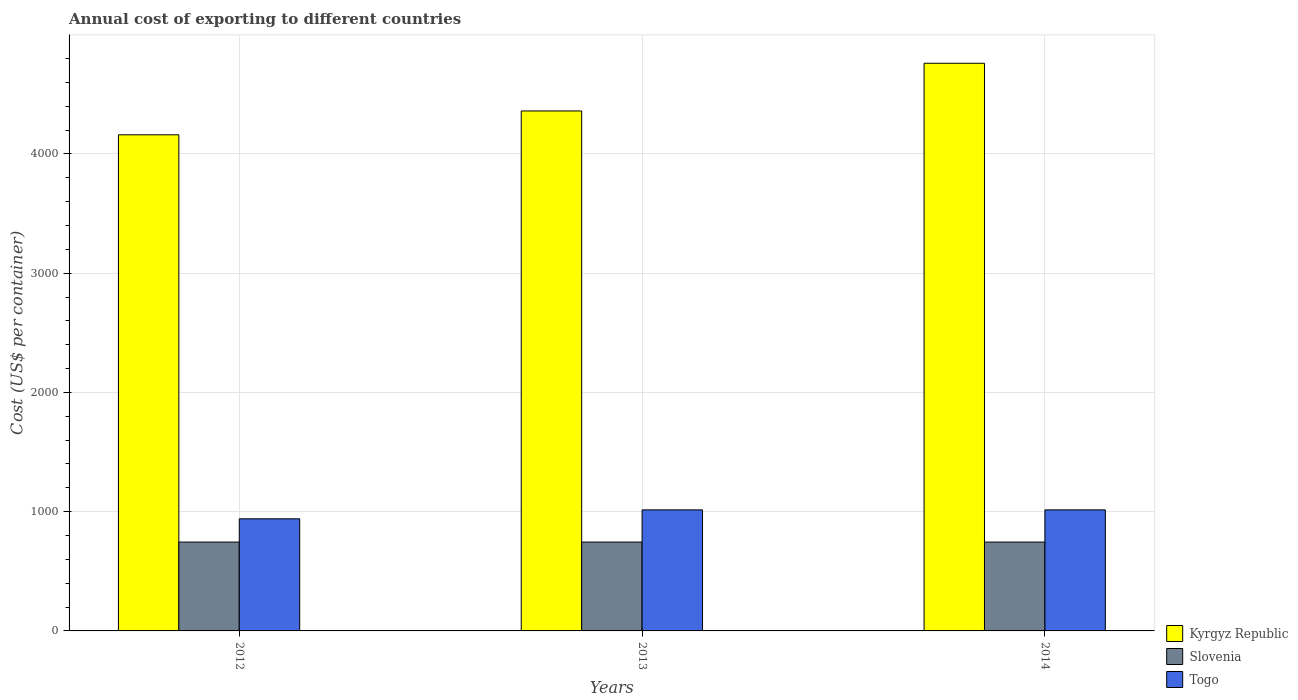Are the number of bars per tick equal to the number of legend labels?
Provide a short and direct response. Yes. Are the number of bars on each tick of the X-axis equal?
Your answer should be very brief. Yes. How many bars are there on the 2nd tick from the left?
Your answer should be very brief. 3. How many bars are there on the 2nd tick from the right?
Provide a short and direct response. 3. In how many cases, is the number of bars for a given year not equal to the number of legend labels?
Offer a very short reply. 0. What is the total annual cost of exporting in Slovenia in 2013?
Provide a short and direct response. 745. Across all years, what is the maximum total annual cost of exporting in Slovenia?
Your answer should be very brief. 745. Across all years, what is the minimum total annual cost of exporting in Kyrgyz Republic?
Your answer should be very brief. 4160. In which year was the total annual cost of exporting in Togo maximum?
Ensure brevity in your answer.  2013. What is the total total annual cost of exporting in Slovenia in the graph?
Give a very brief answer. 2235. What is the difference between the total annual cost of exporting in Slovenia in 2014 and the total annual cost of exporting in Togo in 2013?
Keep it short and to the point. -270. What is the average total annual cost of exporting in Togo per year?
Ensure brevity in your answer.  990. In the year 2013, what is the difference between the total annual cost of exporting in Kyrgyz Republic and total annual cost of exporting in Togo?
Your response must be concise. 3345. What is the ratio of the total annual cost of exporting in Togo in 2012 to that in 2013?
Make the answer very short. 0.93. Is the difference between the total annual cost of exporting in Kyrgyz Republic in 2012 and 2013 greater than the difference between the total annual cost of exporting in Togo in 2012 and 2013?
Your answer should be very brief. No. What is the difference between the highest and the lowest total annual cost of exporting in Togo?
Offer a terse response. 75. Is the sum of the total annual cost of exporting in Slovenia in 2012 and 2013 greater than the maximum total annual cost of exporting in Kyrgyz Republic across all years?
Your answer should be very brief. No. What does the 2nd bar from the left in 2013 represents?
Ensure brevity in your answer.  Slovenia. What does the 1st bar from the right in 2012 represents?
Provide a succinct answer. Togo. Is it the case that in every year, the sum of the total annual cost of exporting in Slovenia and total annual cost of exporting in Togo is greater than the total annual cost of exporting in Kyrgyz Republic?
Your response must be concise. No. How many years are there in the graph?
Your answer should be compact. 3. Does the graph contain grids?
Make the answer very short. Yes. Where does the legend appear in the graph?
Provide a short and direct response. Bottom right. What is the title of the graph?
Your response must be concise. Annual cost of exporting to different countries. Does "Europe(developing only)" appear as one of the legend labels in the graph?
Provide a succinct answer. No. What is the label or title of the X-axis?
Your answer should be very brief. Years. What is the label or title of the Y-axis?
Make the answer very short. Cost (US$ per container). What is the Cost (US$ per container) in Kyrgyz Republic in 2012?
Provide a succinct answer. 4160. What is the Cost (US$ per container) of Slovenia in 2012?
Provide a short and direct response. 745. What is the Cost (US$ per container) of Togo in 2012?
Ensure brevity in your answer.  940. What is the Cost (US$ per container) of Kyrgyz Republic in 2013?
Provide a succinct answer. 4360. What is the Cost (US$ per container) of Slovenia in 2013?
Give a very brief answer. 745. What is the Cost (US$ per container) in Togo in 2013?
Keep it short and to the point. 1015. What is the Cost (US$ per container) in Kyrgyz Republic in 2014?
Your response must be concise. 4760. What is the Cost (US$ per container) of Slovenia in 2014?
Ensure brevity in your answer.  745. What is the Cost (US$ per container) in Togo in 2014?
Provide a succinct answer. 1015. Across all years, what is the maximum Cost (US$ per container) in Kyrgyz Republic?
Ensure brevity in your answer.  4760. Across all years, what is the maximum Cost (US$ per container) in Slovenia?
Your answer should be compact. 745. Across all years, what is the maximum Cost (US$ per container) in Togo?
Your response must be concise. 1015. Across all years, what is the minimum Cost (US$ per container) in Kyrgyz Republic?
Ensure brevity in your answer.  4160. Across all years, what is the minimum Cost (US$ per container) in Slovenia?
Keep it short and to the point. 745. Across all years, what is the minimum Cost (US$ per container) in Togo?
Offer a terse response. 940. What is the total Cost (US$ per container) in Kyrgyz Republic in the graph?
Your answer should be very brief. 1.33e+04. What is the total Cost (US$ per container) in Slovenia in the graph?
Your response must be concise. 2235. What is the total Cost (US$ per container) of Togo in the graph?
Your answer should be very brief. 2970. What is the difference between the Cost (US$ per container) in Kyrgyz Republic in 2012 and that in 2013?
Your answer should be compact. -200. What is the difference between the Cost (US$ per container) in Slovenia in 2012 and that in 2013?
Offer a very short reply. 0. What is the difference between the Cost (US$ per container) of Togo in 2012 and that in 2013?
Your response must be concise. -75. What is the difference between the Cost (US$ per container) of Kyrgyz Republic in 2012 and that in 2014?
Your response must be concise. -600. What is the difference between the Cost (US$ per container) in Togo in 2012 and that in 2014?
Offer a very short reply. -75. What is the difference between the Cost (US$ per container) of Kyrgyz Republic in 2013 and that in 2014?
Your answer should be compact. -400. What is the difference between the Cost (US$ per container) of Slovenia in 2013 and that in 2014?
Your answer should be compact. 0. What is the difference between the Cost (US$ per container) of Togo in 2013 and that in 2014?
Make the answer very short. 0. What is the difference between the Cost (US$ per container) in Kyrgyz Republic in 2012 and the Cost (US$ per container) in Slovenia in 2013?
Your answer should be compact. 3415. What is the difference between the Cost (US$ per container) of Kyrgyz Republic in 2012 and the Cost (US$ per container) of Togo in 2013?
Give a very brief answer. 3145. What is the difference between the Cost (US$ per container) of Slovenia in 2012 and the Cost (US$ per container) of Togo in 2013?
Make the answer very short. -270. What is the difference between the Cost (US$ per container) in Kyrgyz Republic in 2012 and the Cost (US$ per container) in Slovenia in 2014?
Your response must be concise. 3415. What is the difference between the Cost (US$ per container) of Kyrgyz Republic in 2012 and the Cost (US$ per container) of Togo in 2014?
Provide a succinct answer. 3145. What is the difference between the Cost (US$ per container) in Slovenia in 2012 and the Cost (US$ per container) in Togo in 2014?
Your response must be concise. -270. What is the difference between the Cost (US$ per container) in Kyrgyz Republic in 2013 and the Cost (US$ per container) in Slovenia in 2014?
Give a very brief answer. 3615. What is the difference between the Cost (US$ per container) in Kyrgyz Republic in 2013 and the Cost (US$ per container) in Togo in 2014?
Keep it short and to the point. 3345. What is the difference between the Cost (US$ per container) of Slovenia in 2013 and the Cost (US$ per container) of Togo in 2014?
Provide a short and direct response. -270. What is the average Cost (US$ per container) of Kyrgyz Republic per year?
Your response must be concise. 4426.67. What is the average Cost (US$ per container) in Slovenia per year?
Make the answer very short. 745. What is the average Cost (US$ per container) in Togo per year?
Your answer should be compact. 990. In the year 2012, what is the difference between the Cost (US$ per container) in Kyrgyz Republic and Cost (US$ per container) in Slovenia?
Keep it short and to the point. 3415. In the year 2012, what is the difference between the Cost (US$ per container) in Kyrgyz Republic and Cost (US$ per container) in Togo?
Your response must be concise. 3220. In the year 2012, what is the difference between the Cost (US$ per container) in Slovenia and Cost (US$ per container) in Togo?
Your answer should be very brief. -195. In the year 2013, what is the difference between the Cost (US$ per container) in Kyrgyz Republic and Cost (US$ per container) in Slovenia?
Make the answer very short. 3615. In the year 2013, what is the difference between the Cost (US$ per container) of Kyrgyz Republic and Cost (US$ per container) of Togo?
Make the answer very short. 3345. In the year 2013, what is the difference between the Cost (US$ per container) of Slovenia and Cost (US$ per container) of Togo?
Keep it short and to the point. -270. In the year 2014, what is the difference between the Cost (US$ per container) of Kyrgyz Republic and Cost (US$ per container) of Slovenia?
Offer a terse response. 4015. In the year 2014, what is the difference between the Cost (US$ per container) of Kyrgyz Republic and Cost (US$ per container) of Togo?
Offer a very short reply. 3745. In the year 2014, what is the difference between the Cost (US$ per container) of Slovenia and Cost (US$ per container) of Togo?
Offer a very short reply. -270. What is the ratio of the Cost (US$ per container) in Kyrgyz Republic in 2012 to that in 2013?
Offer a terse response. 0.95. What is the ratio of the Cost (US$ per container) in Togo in 2012 to that in 2013?
Your response must be concise. 0.93. What is the ratio of the Cost (US$ per container) in Kyrgyz Republic in 2012 to that in 2014?
Your response must be concise. 0.87. What is the ratio of the Cost (US$ per container) in Togo in 2012 to that in 2014?
Ensure brevity in your answer.  0.93. What is the ratio of the Cost (US$ per container) in Kyrgyz Republic in 2013 to that in 2014?
Your answer should be very brief. 0.92. What is the ratio of the Cost (US$ per container) of Slovenia in 2013 to that in 2014?
Your answer should be very brief. 1. What is the ratio of the Cost (US$ per container) in Togo in 2013 to that in 2014?
Your answer should be very brief. 1. What is the difference between the highest and the second highest Cost (US$ per container) in Togo?
Ensure brevity in your answer.  0. What is the difference between the highest and the lowest Cost (US$ per container) of Kyrgyz Republic?
Ensure brevity in your answer.  600. 